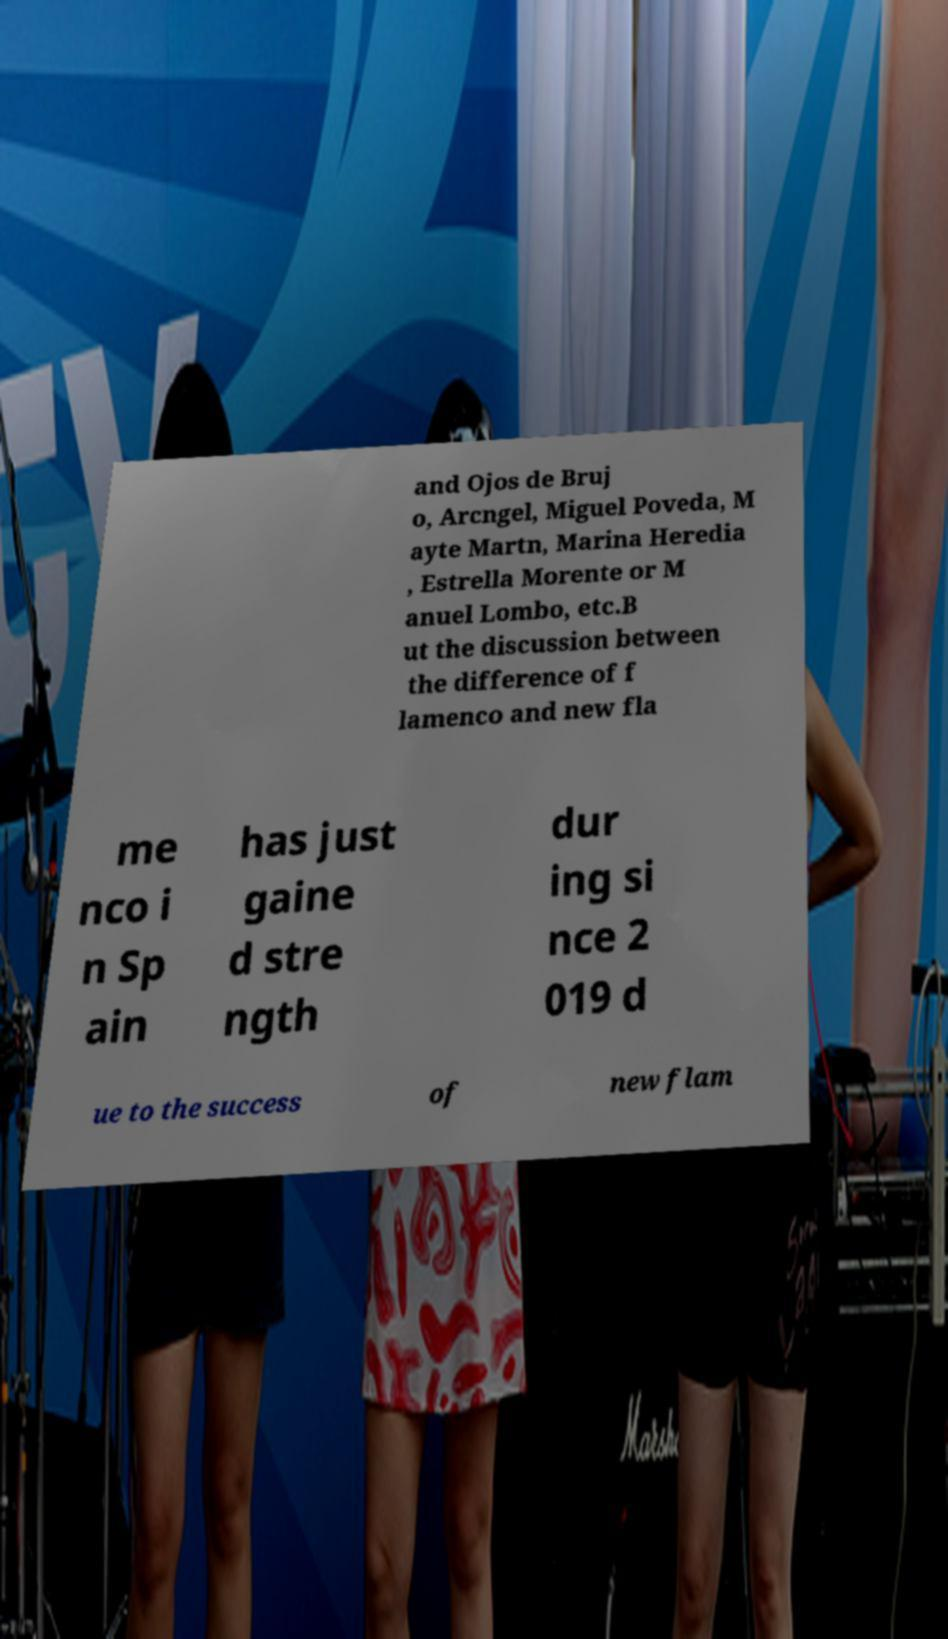Can you accurately transcribe the text from the provided image for me? and Ojos de Bruj o, Arcngel, Miguel Poveda, M ayte Martn, Marina Heredia , Estrella Morente or M anuel Lombo, etc.B ut the discussion between the difference of f lamenco and new fla me nco i n Sp ain has just gaine d stre ngth dur ing si nce 2 019 d ue to the success of new flam 